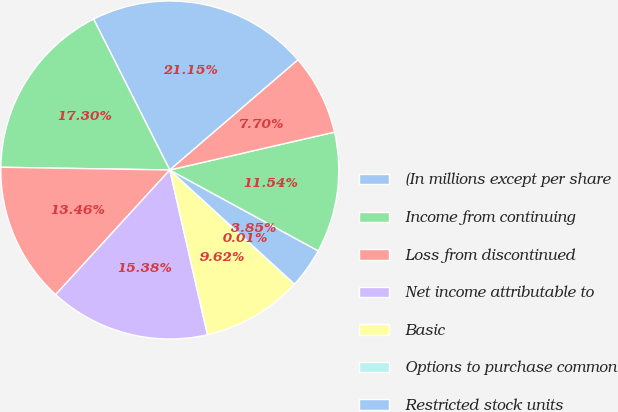Convert chart. <chart><loc_0><loc_0><loc_500><loc_500><pie_chart><fcel>(In millions except per share<fcel>Income from continuing<fcel>Loss from discontinued<fcel>Net income attributable to<fcel>Basic<fcel>Options to purchase common<fcel>Restricted stock units<fcel>Diluted<fcel>Continuing operations<nl><fcel>21.15%<fcel>17.3%<fcel>13.46%<fcel>15.38%<fcel>9.62%<fcel>0.01%<fcel>3.85%<fcel>11.54%<fcel>7.7%<nl></chart> 